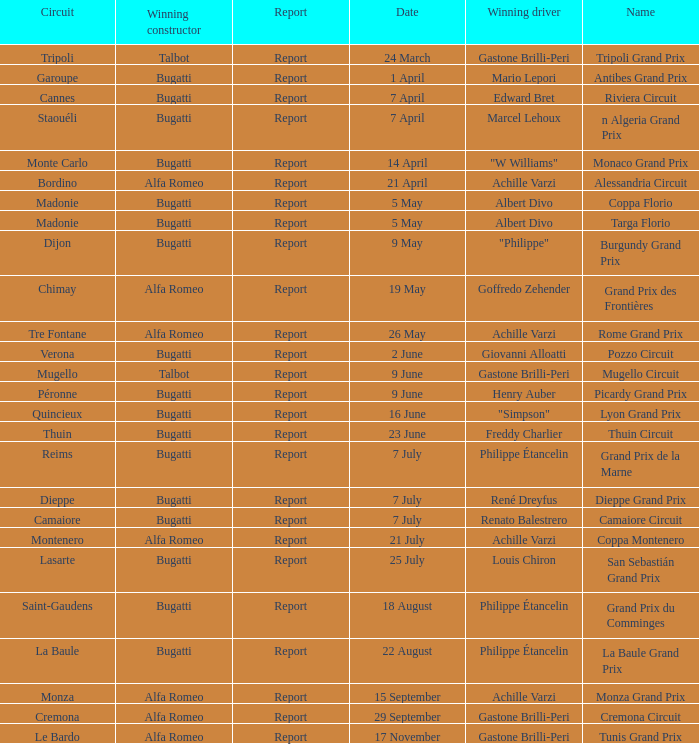What Circuit has a Date of 25 july? Lasarte. 